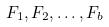Convert formula to latex. <formula><loc_0><loc_0><loc_500><loc_500>F _ { 1 } , F _ { 2 } , \dots , F _ { b }</formula> 